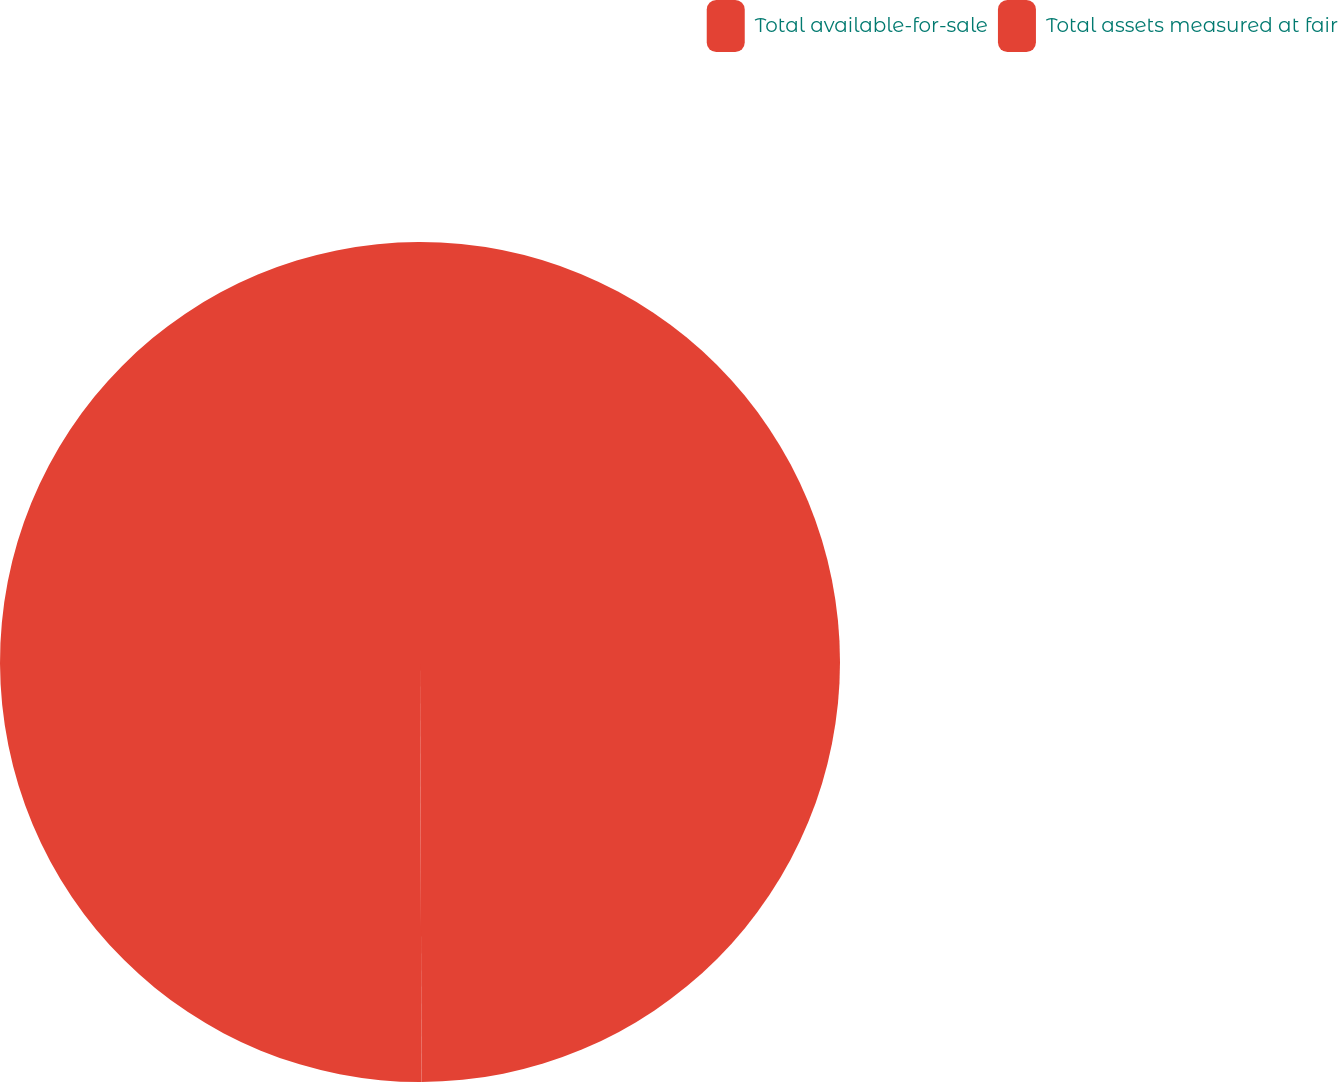Convert chart. <chart><loc_0><loc_0><loc_500><loc_500><pie_chart><fcel>Total available-for-sale<fcel>Total assets measured at fair<nl><fcel>49.94%<fcel>50.06%<nl></chart> 